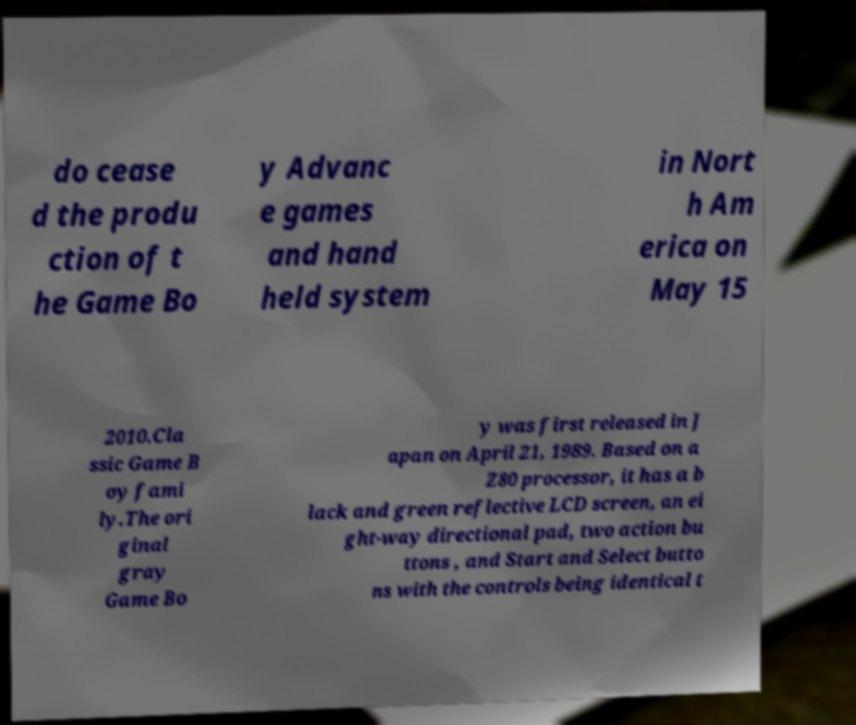Could you assist in decoding the text presented in this image and type it out clearly? do cease d the produ ction of t he Game Bo y Advanc e games and hand held system in Nort h Am erica on May 15 2010.Cla ssic Game B oy fami ly.The ori ginal gray Game Bo y was first released in J apan on April 21, 1989. Based on a Z80 processor, it has a b lack and green reflective LCD screen, an ei ght-way directional pad, two action bu ttons , and Start and Select butto ns with the controls being identical t 